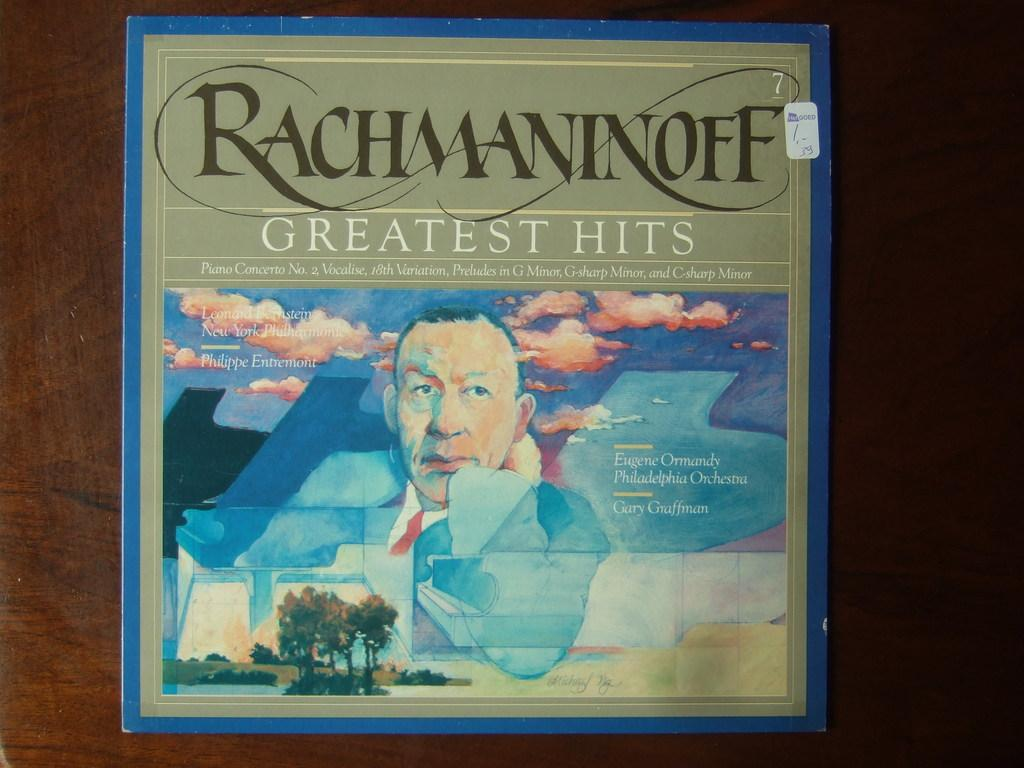What is the main object in the image? There is a book in the image. What is the title of the book? The book is titled "Rich man in off". What can be seen on the cover page of the book? The cover page of the book features a painting. What elements are included in the painting? The painting includes a man, trees, and a cloudy sky. What type of jam is being spread on the man's eye in the painting? There is no jam or any reference to spreading it on the man's eye in the painting; the painting only includes a man, trees, and a cloudy sky. 